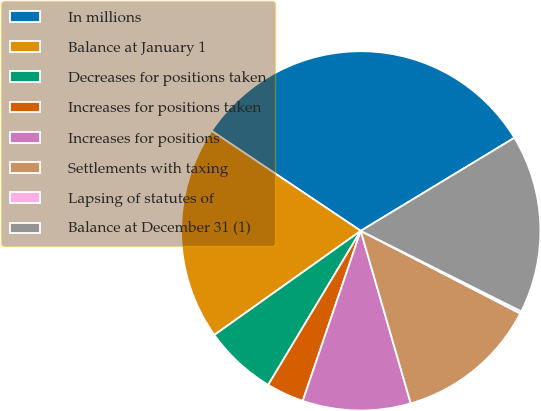Convert chart. <chart><loc_0><loc_0><loc_500><loc_500><pie_chart><fcel>In millions<fcel>Balance at January 1<fcel>Decreases for positions taken<fcel>Increases for positions taken<fcel>Increases for positions<fcel>Settlements with taxing<fcel>Lapsing of statutes of<fcel>Balance at December 31 (1)<nl><fcel>31.93%<fcel>19.24%<fcel>6.55%<fcel>3.38%<fcel>9.72%<fcel>12.9%<fcel>0.21%<fcel>16.07%<nl></chart> 